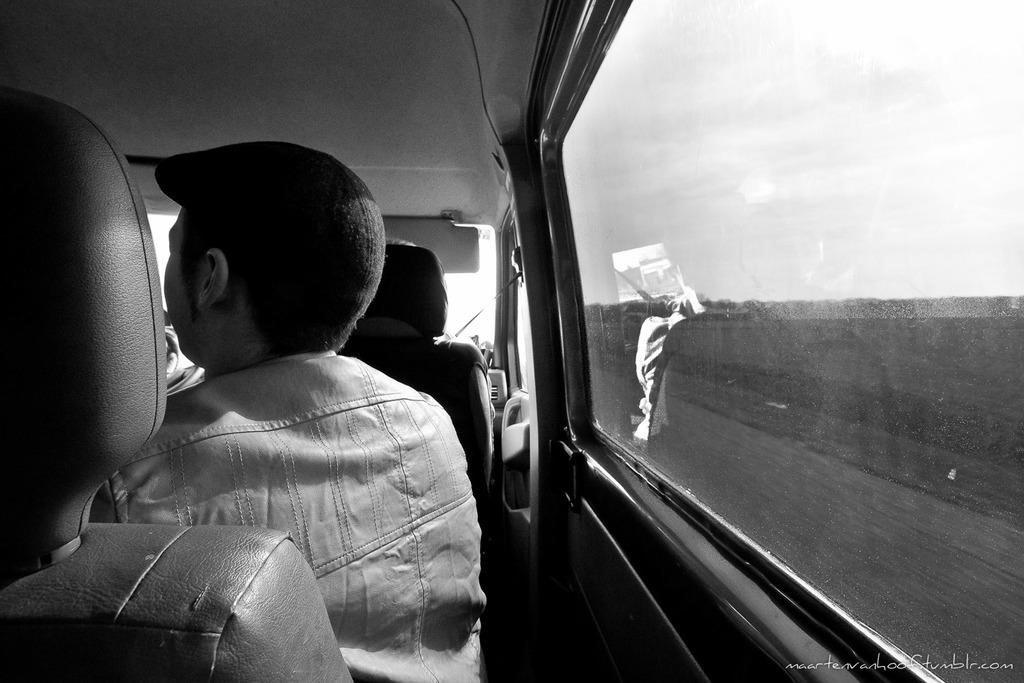How many people are in the image? There are persons in the image. What are the persons doing in the image? The persons are sitting in seats. Where are the seats located? The seats are in a vehicle. What type of skate is being used by the persons in the image? There is no skate present in the image; the persons are sitting in seats in a vehicle. 